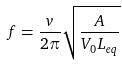<formula> <loc_0><loc_0><loc_500><loc_500>f = \frac { v } { 2 \pi } \sqrt { \frac { A } { V _ { 0 } L _ { e q } } }</formula> 